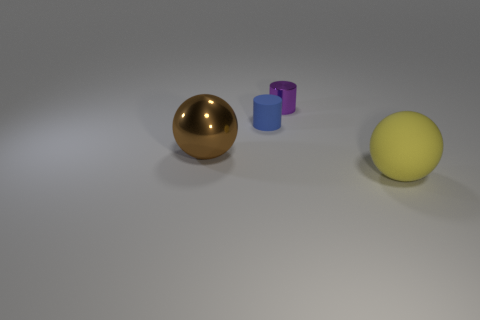Add 3 shiny cylinders. How many objects exist? 7 Add 3 large yellow shiny cylinders. How many large yellow shiny cylinders exist? 3 Subtract 0 gray balls. How many objects are left? 4 Subtract all tiny blue rubber things. Subtract all yellow things. How many objects are left? 2 Add 2 rubber cylinders. How many rubber cylinders are left? 3 